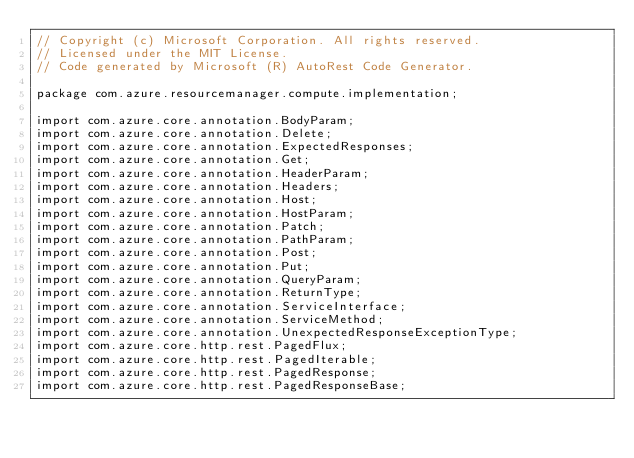Convert code to text. <code><loc_0><loc_0><loc_500><loc_500><_Java_>// Copyright (c) Microsoft Corporation. All rights reserved.
// Licensed under the MIT License.
// Code generated by Microsoft (R) AutoRest Code Generator.

package com.azure.resourcemanager.compute.implementation;

import com.azure.core.annotation.BodyParam;
import com.azure.core.annotation.Delete;
import com.azure.core.annotation.ExpectedResponses;
import com.azure.core.annotation.Get;
import com.azure.core.annotation.HeaderParam;
import com.azure.core.annotation.Headers;
import com.azure.core.annotation.Host;
import com.azure.core.annotation.HostParam;
import com.azure.core.annotation.Patch;
import com.azure.core.annotation.PathParam;
import com.azure.core.annotation.Post;
import com.azure.core.annotation.Put;
import com.azure.core.annotation.QueryParam;
import com.azure.core.annotation.ReturnType;
import com.azure.core.annotation.ServiceInterface;
import com.azure.core.annotation.ServiceMethod;
import com.azure.core.annotation.UnexpectedResponseExceptionType;
import com.azure.core.http.rest.PagedFlux;
import com.azure.core.http.rest.PagedIterable;
import com.azure.core.http.rest.PagedResponse;
import com.azure.core.http.rest.PagedResponseBase;</code> 